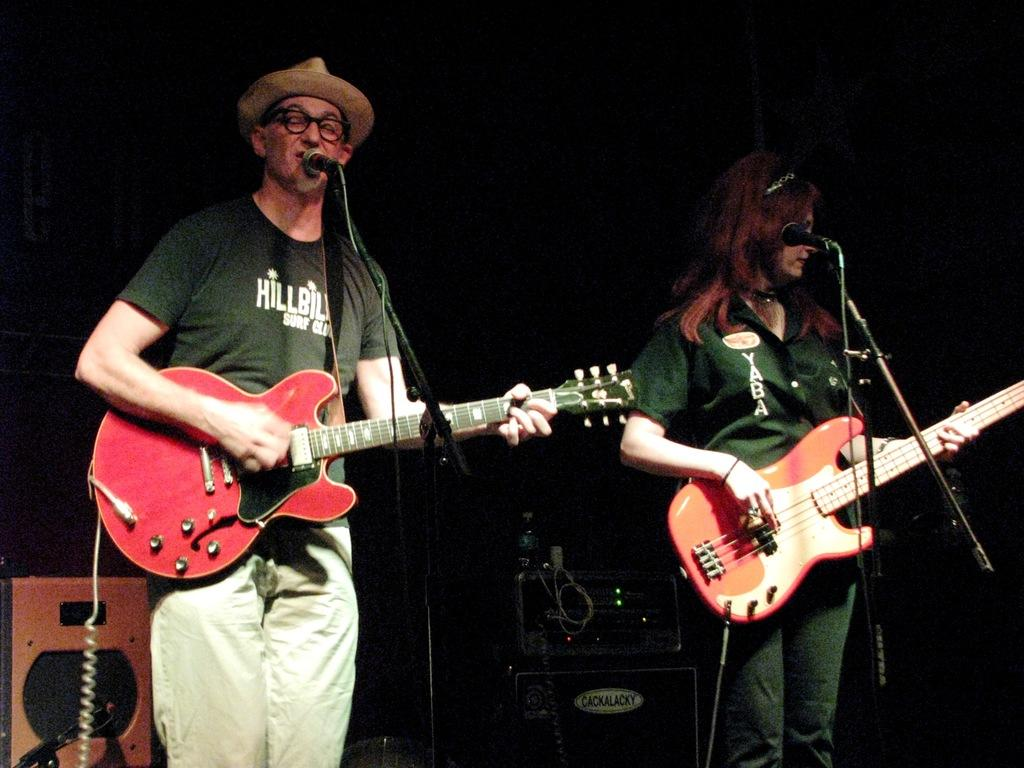How many people are in the image? There are two people in the image, a man and a woman. What are the man and woman doing in the image? The man and woman are standing on a stage and playing guitars. What can be seen in the background of the image? There is a speaker box and a water bottle in the background of the image. What type of soap is the man using to clean his guitar in the image? There is no soap or guitar cleaning activity present in the image. 